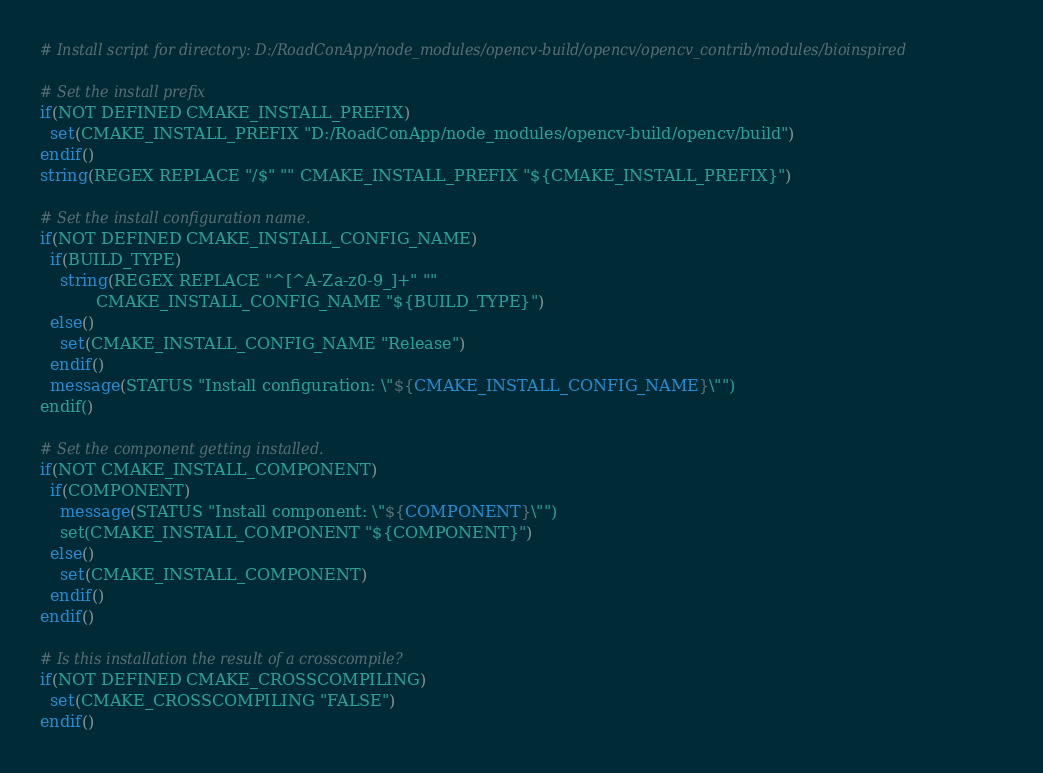<code> <loc_0><loc_0><loc_500><loc_500><_CMake_># Install script for directory: D:/RoadConApp/node_modules/opencv-build/opencv/opencv_contrib/modules/bioinspired

# Set the install prefix
if(NOT DEFINED CMAKE_INSTALL_PREFIX)
  set(CMAKE_INSTALL_PREFIX "D:/RoadConApp/node_modules/opencv-build/opencv/build")
endif()
string(REGEX REPLACE "/$" "" CMAKE_INSTALL_PREFIX "${CMAKE_INSTALL_PREFIX}")

# Set the install configuration name.
if(NOT DEFINED CMAKE_INSTALL_CONFIG_NAME)
  if(BUILD_TYPE)
    string(REGEX REPLACE "^[^A-Za-z0-9_]+" ""
           CMAKE_INSTALL_CONFIG_NAME "${BUILD_TYPE}")
  else()
    set(CMAKE_INSTALL_CONFIG_NAME "Release")
  endif()
  message(STATUS "Install configuration: \"${CMAKE_INSTALL_CONFIG_NAME}\"")
endif()

# Set the component getting installed.
if(NOT CMAKE_INSTALL_COMPONENT)
  if(COMPONENT)
    message(STATUS "Install component: \"${COMPONENT}\"")
    set(CMAKE_INSTALL_COMPONENT "${COMPONENT}")
  else()
    set(CMAKE_INSTALL_COMPONENT)
  endif()
endif()

# Is this installation the result of a crosscompile?
if(NOT DEFINED CMAKE_CROSSCOMPILING)
  set(CMAKE_CROSSCOMPILING "FALSE")
endif()

</code> 